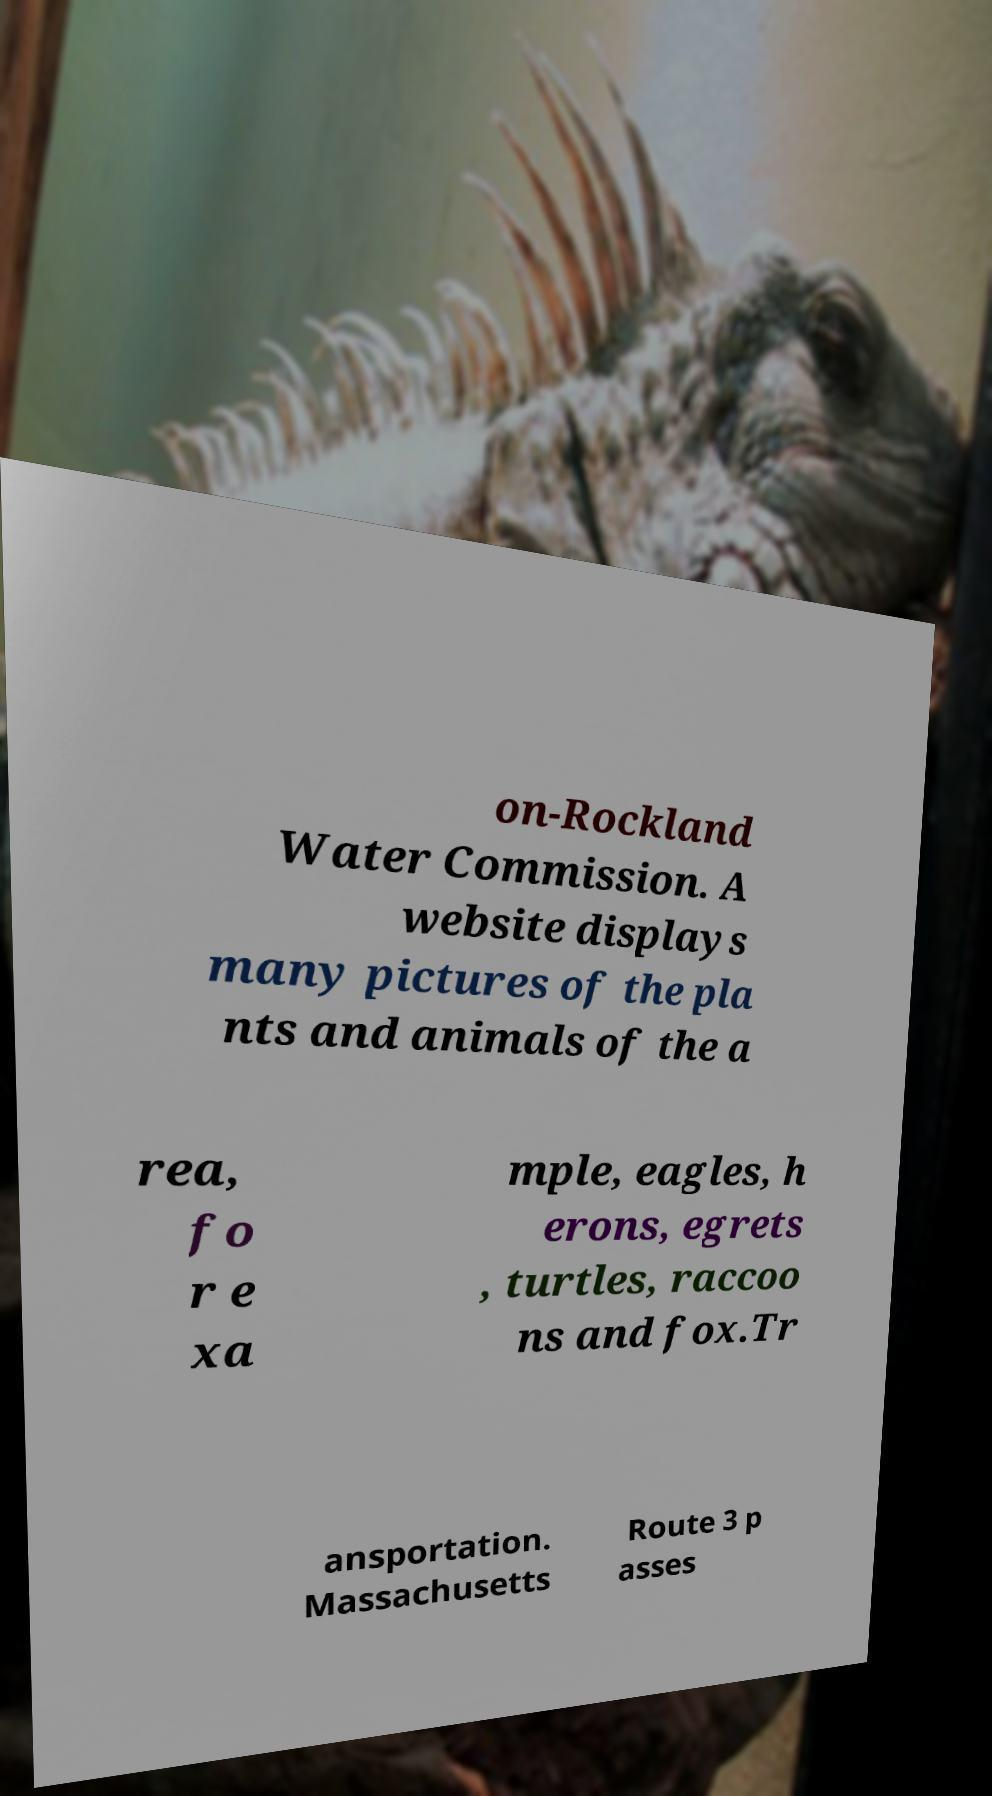Could you assist in decoding the text presented in this image and type it out clearly? on-Rockland Water Commission. A website displays many pictures of the pla nts and animals of the a rea, fo r e xa mple, eagles, h erons, egrets , turtles, raccoo ns and fox.Tr ansportation. Massachusetts Route 3 p asses 